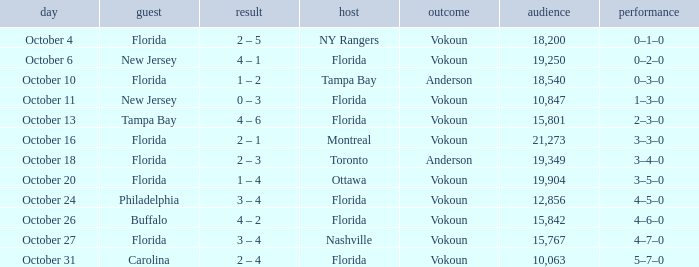Which team won when the visitor was Carolina? Vokoun. 